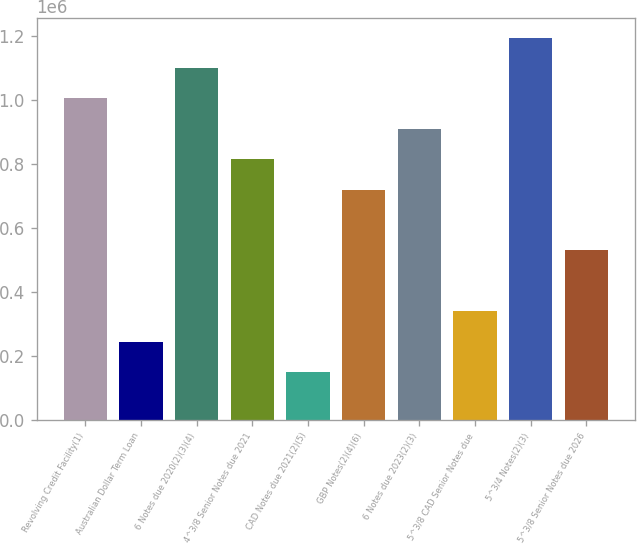Convert chart. <chart><loc_0><loc_0><loc_500><loc_500><bar_chart><fcel>Revolving Credit Facility(1)<fcel>Australian Dollar Term Loan<fcel>6 Notes due 2020(2)(3)(4)<fcel>4^3/8 Senior Notes due 2021<fcel>CAD Notes due 2021(2)(5)<fcel>GBP Notes(2)(4)(6)<fcel>6 Notes due 2023(2)(3)<fcel>5^3/8 CAD Senior Notes due<fcel>5^3/4 Notes(2)(3)<fcel>5^3/8 Senior Notes due 2026<nl><fcel>1.00379e+06<fcel>243792<fcel>1.09879e+06<fcel>813792<fcel>148792<fcel>718792<fcel>908792<fcel>338792<fcel>1.19379e+06<fcel>528792<nl></chart> 